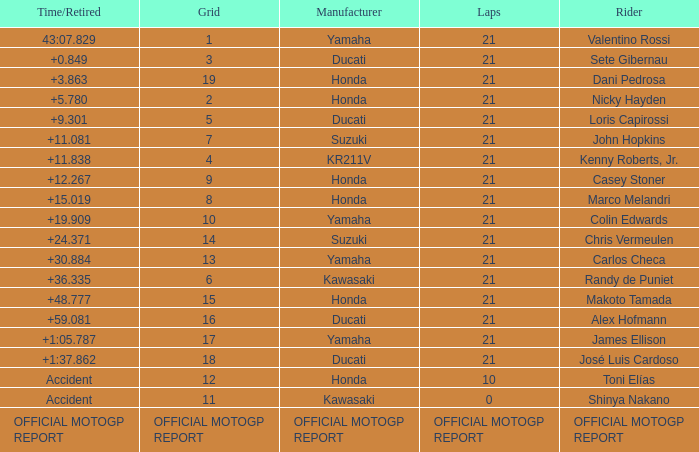WWhich rder had a vehicle manufactured by kr211v? Kenny Roberts, Jr. 